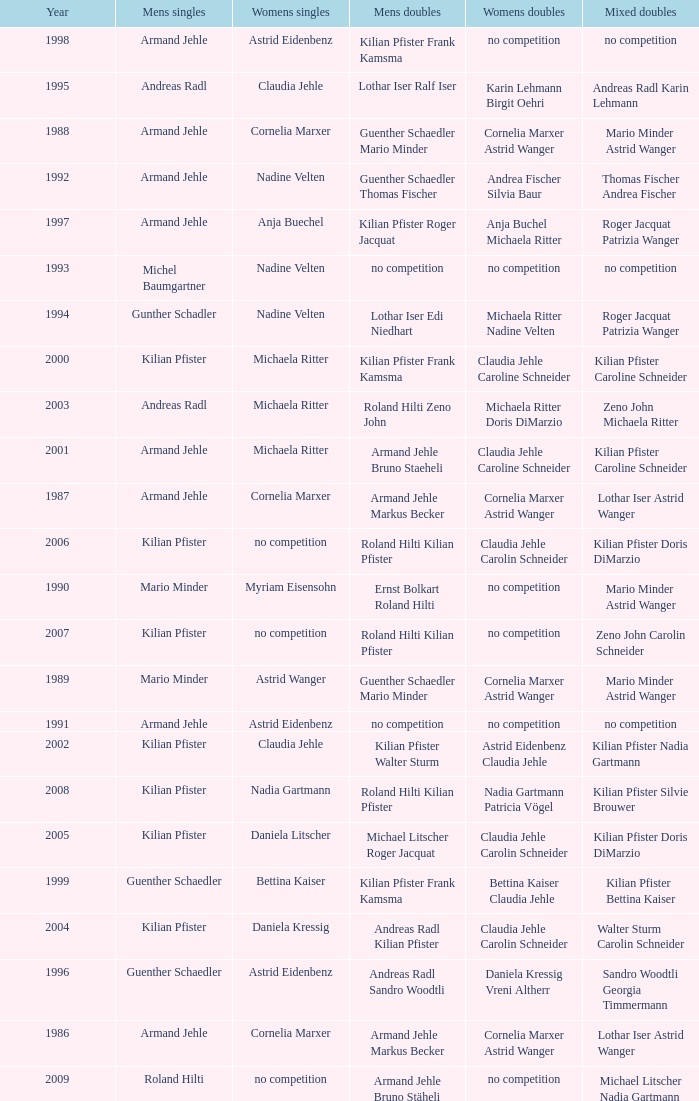Can you give me this table as a dict? {'header': ['Year', 'Mens singles', 'Womens singles', 'Mens doubles', 'Womens doubles', 'Mixed doubles'], 'rows': [['1998', 'Armand Jehle', 'Astrid Eidenbenz', 'Kilian Pfister Frank Kamsma', 'no competition', 'no competition'], ['1995', 'Andreas Radl', 'Claudia Jehle', 'Lothar Iser Ralf Iser', 'Karin Lehmann Birgit Oehri', 'Andreas Radl Karin Lehmann'], ['1988', 'Armand Jehle', 'Cornelia Marxer', 'Guenther Schaedler Mario Minder', 'Cornelia Marxer Astrid Wanger', 'Mario Minder Astrid Wanger'], ['1992', 'Armand Jehle', 'Nadine Velten', 'Guenther Schaedler Thomas Fischer', 'Andrea Fischer Silvia Baur', 'Thomas Fischer Andrea Fischer'], ['1997', 'Armand Jehle', 'Anja Buechel', 'Kilian Pfister Roger Jacquat', 'Anja Buchel Michaela Ritter', 'Roger Jacquat Patrizia Wanger'], ['1993', 'Michel Baumgartner', 'Nadine Velten', 'no competition', 'no competition', 'no competition'], ['1994', 'Gunther Schadler', 'Nadine Velten', 'Lothar Iser Edi Niedhart', 'Michaela Ritter Nadine Velten', 'Roger Jacquat Patrizia Wanger'], ['2000', 'Kilian Pfister', 'Michaela Ritter', 'Kilian Pfister Frank Kamsma', 'Claudia Jehle Caroline Schneider', 'Kilian Pfister Caroline Schneider'], ['2003', 'Andreas Radl', 'Michaela Ritter', 'Roland Hilti Zeno John', 'Michaela Ritter Doris DiMarzio', 'Zeno John Michaela Ritter'], ['2001', 'Armand Jehle', 'Michaela Ritter', 'Armand Jehle Bruno Staeheli', 'Claudia Jehle Caroline Schneider', 'Kilian Pfister Caroline Schneider'], ['1987', 'Armand Jehle', 'Cornelia Marxer', 'Armand Jehle Markus Becker', 'Cornelia Marxer Astrid Wanger', 'Lothar Iser Astrid Wanger'], ['2006', 'Kilian Pfister', 'no competition', 'Roland Hilti Kilian Pfister', 'Claudia Jehle Carolin Schneider', 'Kilian Pfister Doris DiMarzio'], ['1990', 'Mario Minder', 'Myriam Eisensohn', 'Ernst Bolkart Roland Hilti', 'no competition', 'Mario Minder Astrid Wanger'], ['2007', 'Kilian Pfister', 'no competition', 'Roland Hilti Kilian Pfister', 'no competition', 'Zeno John Carolin Schneider'], ['1989', 'Mario Minder', 'Astrid Wanger', 'Guenther Schaedler Mario Minder', 'Cornelia Marxer Astrid Wanger', 'Mario Minder Astrid Wanger'], ['1991', 'Armand Jehle', 'Astrid Eidenbenz', 'no competition', 'no competition', 'no competition'], ['2002', 'Kilian Pfister', 'Claudia Jehle', 'Kilian Pfister Walter Sturm', 'Astrid Eidenbenz Claudia Jehle', 'Kilian Pfister Nadia Gartmann'], ['2008', 'Kilian Pfister', 'Nadia Gartmann', 'Roland Hilti Kilian Pfister', 'Nadia Gartmann Patricia Vögel', 'Kilian Pfister Silvie Brouwer'], ['2005', 'Kilian Pfister', 'Daniela Litscher', 'Michael Litscher Roger Jacquat', 'Claudia Jehle Carolin Schneider', 'Kilian Pfister Doris DiMarzio'], ['1999', 'Guenther Schaedler', 'Bettina Kaiser', 'Kilian Pfister Frank Kamsma', 'Bettina Kaiser Claudia Jehle', 'Kilian Pfister Bettina Kaiser'], ['2004', 'Kilian Pfister', 'Daniela Kressig', 'Andreas Radl Kilian Pfister', 'Claudia Jehle Carolin Schneider', 'Walter Sturm Carolin Schneider'], ['1996', 'Guenther Schaedler', 'Astrid Eidenbenz', 'Andreas Radl Sandro Woodtli', 'Daniela Kressig Vreni Altherr', 'Sandro Woodtli Georgia Timmermann'], ['1986', 'Armand Jehle', 'Cornelia Marxer', 'Armand Jehle Markus Becker', 'Cornelia Marxer Astrid Wanger', 'Lothar Iser Astrid Wanger'], ['2009', 'Roland Hilti', 'no competition', 'Armand Jehle Bruno Stäheli', 'no competition', 'Michael Litscher Nadia Gartmann']]} In the year 2006, the womens singles had no competition and the mens doubles were roland hilti kilian pfister, what were the womens doubles Claudia Jehle Carolin Schneider. 